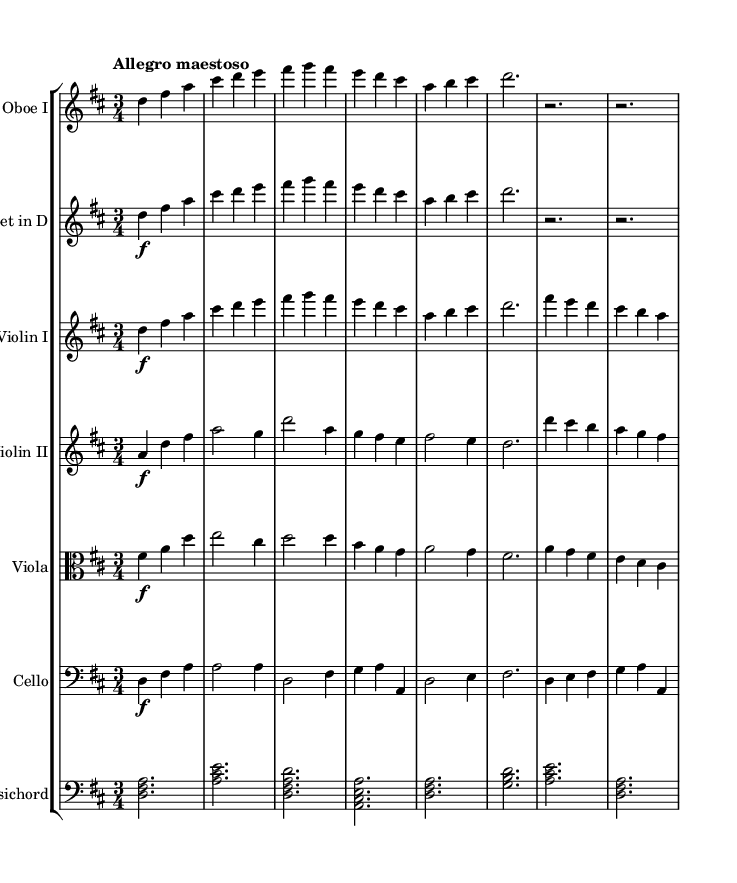What is the key signature of this music? The key signature is indicated at the beginning of the staff; it shows two sharps, which corresponds to D major.
Answer: D major What is the time signature of this piece? The time signature is located just after the key signature at the beginning of the music, and it shows 3/4, indicating three beats per measure.
Answer: 3/4 What is the tempo marking for this piece? The tempo marking is located above the staff, describing the speed of the piece as "Allegro maestoso," which means a fast tempo with a majestic character.
Answer: Allegro maestoso Which instruments are included in this orchestral suite? The list of instruments is shown at the beginning of each staff in the score; they include Oboe I, Trumpet in D, Violin I, Violin II, Viola, Cello, and Harpsichord.
Answer: Oboe I, Trumpet in D, Violin I, Violin II, Viola, Cello, Harpsichord What is the range of the first violin part? To determine the range, we look at the notes in the Violin I staff, which span from D in the lower register to approximately a high A. The overall range can be observed from the lowest note to the highest note in the part.
Answer: D to A How does the orchestration reflect Baroque traditions? The orchestration typically involves strings, woodwinds, and the harpsichord, which are the standard ensembles of the Baroque period, often used to create contrasting textures and layers in the music, reflective of the sophisticated royal court influences.
Answer: Strings, woodwinds, harpsichord What is the role of the harpsichord in this suite? The harpsichord serves as both a continuo instrument and a harmonic foundation, often providing rhythmic and harmonic support, characteristic of Baroque orchestral pieces where it supports the harmony while being more subdued in dynamics.
Answer: Continuo instrument 